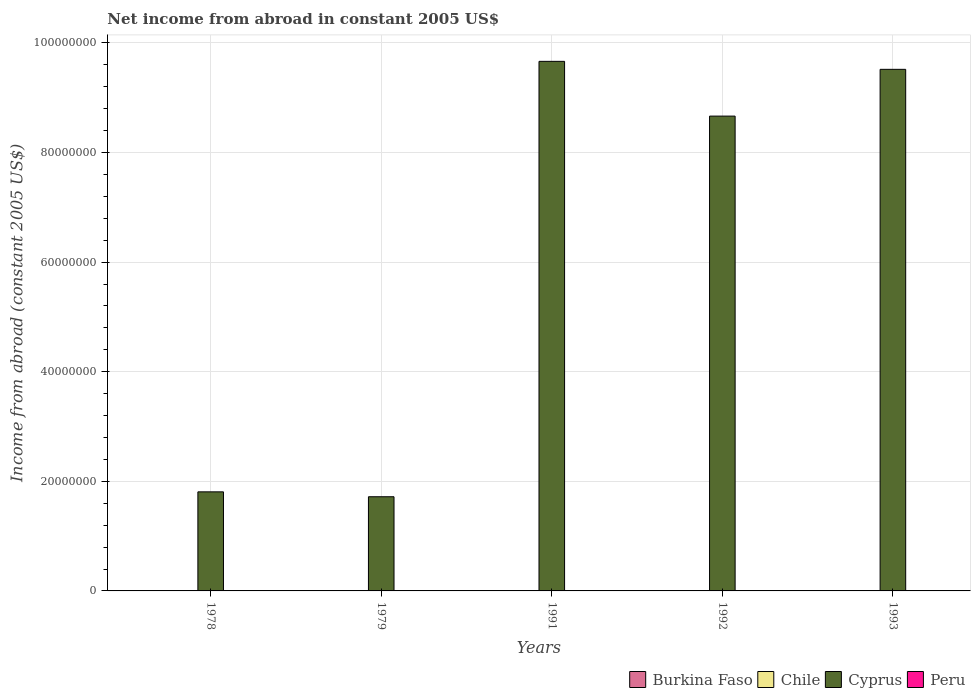Are the number of bars on each tick of the X-axis equal?
Provide a short and direct response. Yes. How many bars are there on the 4th tick from the left?
Provide a succinct answer. 1. What is the label of the 4th group of bars from the left?
Offer a very short reply. 1992. What is the net income from abroad in Cyprus in 1978?
Your answer should be very brief. 1.81e+07. Across all years, what is the minimum net income from abroad in Peru?
Give a very brief answer. 0. In which year was the net income from abroad in Cyprus maximum?
Your response must be concise. 1991. What is the difference between the net income from abroad in Cyprus in 1979 and that in 1993?
Your response must be concise. -7.80e+07. What is the ratio of the net income from abroad in Cyprus in 1978 to that in 1992?
Make the answer very short. 0.21. Is the net income from abroad in Cyprus in 1979 less than that in 1993?
Make the answer very short. Yes. What is the difference between the highest and the lowest net income from abroad in Cyprus?
Ensure brevity in your answer.  7.95e+07. In how many years, is the net income from abroad in Chile greater than the average net income from abroad in Chile taken over all years?
Your answer should be compact. 0. Is it the case that in every year, the sum of the net income from abroad in Cyprus and net income from abroad in Peru is greater than the net income from abroad in Burkina Faso?
Provide a short and direct response. Yes. Are the values on the major ticks of Y-axis written in scientific E-notation?
Provide a short and direct response. No. Does the graph contain any zero values?
Your response must be concise. Yes. Where does the legend appear in the graph?
Offer a very short reply. Bottom right. How are the legend labels stacked?
Your response must be concise. Horizontal. What is the title of the graph?
Give a very brief answer. Net income from abroad in constant 2005 US$. What is the label or title of the Y-axis?
Your answer should be compact. Income from abroad (constant 2005 US$). What is the Income from abroad (constant 2005 US$) in Burkina Faso in 1978?
Give a very brief answer. 0. What is the Income from abroad (constant 2005 US$) in Chile in 1978?
Your answer should be very brief. 0. What is the Income from abroad (constant 2005 US$) of Cyprus in 1978?
Give a very brief answer. 1.81e+07. What is the Income from abroad (constant 2005 US$) of Peru in 1978?
Make the answer very short. 0. What is the Income from abroad (constant 2005 US$) in Burkina Faso in 1979?
Ensure brevity in your answer.  0. What is the Income from abroad (constant 2005 US$) of Cyprus in 1979?
Your response must be concise. 1.72e+07. What is the Income from abroad (constant 2005 US$) in Peru in 1979?
Give a very brief answer. 0. What is the Income from abroad (constant 2005 US$) in Cyprus in 1991?
Keep it short and to the point. 9.66e+07. What is the Income from abroad (constant 2005 US$) in Chile in 1992?
Give a very brief answer. 0. What is the Income from abroad (constant 2005 US$) in Cyprus in 1992?
Keep it short and to the point. 8.67e+07. What is the Income from abroad (constant 2005 US$) of Peru in 1992?
Offer a terse response. 0. What is the Income from abroad (constant 2005 US$) of Burkina Faso in 1993?
Provide a short and direct response. 0. What is the Income from abroad (constant 2005 US$) of Cyprus in 1993?
Give a very brief answer. 9.52e+07. Across all years, what is the maximum Income from abroad (constant 2005 US$) in Cyprus?
Your answer should be very brief. 9.66e+07. Across all years, what is the minimum Income from abroad (constant 2005 US$) of Cyprus?
Provide a short and direct response. 1.72e+07. What is the total Income from abroad (constant 2005 US$) in Chile in the graph?
Your answer should be very brief. 0. What is the total Income from abroad (constant 2005 US$) of Cyprus in the graph?
Offer a very short reply. 3.14e+08. What is the difference between the Income from abroad (constant 2005 US$) in Cyprus in 1978 and that in 1979?
Offer a terse response. 8.93e+05. What is the difference between the Income from abroad (constant 2005 US$) of Cyprus in 1978 and that in 1991?
Offer a very short reply. -7.86e+07. What is the difference between the Income from abroad (constant 2005 US$) of Cyprus in 1978 and that in 1992?
Provide a succinct answer. -6.86e+07. What is the difference between the Income from abroad (constant 2005 US$) of Cyprus in 1978 and that in 1993?
Provide a short and direct response. -7.71e+07. What is the difference between the Income from abroad (constant 2005 US$) of Cyprus in 1979 and that in 1991?
Give a very brief answer. -7.95e+07. What is the difference between the Income from abroad (constant 2005 US$) in Cyprus in 1979 and that in 1992?
Provide a succinct answer. -6.95e+07. What is the difference between the Income from abroad (constant 2005 US$) in Cyprus in 1979 and that in 1993?
Your answer should be very brief. -7.80e+07. What is the difference between the Income from abroad (constant 2005 US$) in Cyprus in 1991 and that in 1992?
Keep it short and to the point. 9.99e+06. What is the difference between the Income from abroad (constant 2005 US$) of Cyprus in 1991 and that in 1993?
Provide a succinct answer. 1.46e+06. What is the difference between the Income from abroad (constant 2005 US$) in Cyprus in 1992 and that in 1993?
Your answer should be very brief. -8.54e+06. What is the average Income from abroad (constant 2005 US$) in Cyprus per year?
Give a very brief answer. 6.28e+07. What is the ratio of the Income from abroad (constant 2005 US$) in Cyprus in 1978 to that in 1979?
Your answer should be very brief. 1.05. What is the ratio of the Income from abroad (constant 2005 US$) in Cyprus in 1978 to that in 1991?
Make the answer very short. 0.19. What is the ratio of the Income from abroad (constant 2005 US$) of Cyprus in 1978 to that in 1992?
Your answer should be very brief. 0.21. What is the ratio of the Income from abroad (constant 2005 US$) of Cyprus in 1978 to that in 1993?
Provide a short and direct response. 0.19. What is the ratio of the Income from abroad (constant 2005 US$) of Cyprus in 1979 to that in 1991?
Make the answer very short. 0.18. What is the ratio of the Income from abroad (constant 2005 US$) in Cyprus in 1979 to that in 1992?
Your answer should be very brief. 0.2. What is the ratio of the Income from abroad (constant 2005 US$) in Cyprus in 1979 to that in 1993?
Give a very brief answer. 0.18. What is the ratio of the Income from abroad (constant 2005 US$) of Cyprus in 1991 to that in 1992?
Provide a short and direct response. 1.12. What is the ratio of the Income from abroad (constant 2005 US$) of Cyprus in 1991 to that in 1993?
Give a very brief answer. 1.02. What is the ratio of the Income from abroad (constant 2005 US$) in Cyprus in 1992 to that in 1993?
Make the answer very short. 0.91. What is the difference between the highest and the second highest Income from abroad (constant 2005 US$) in Cyprus?
Provide a succinct answer. 1.46e+06. What is the difference between the highest and the lowest Income from abroad (constant 2005 US$) of Cyprus?
Your answer should be compact. 7.95e+07. 